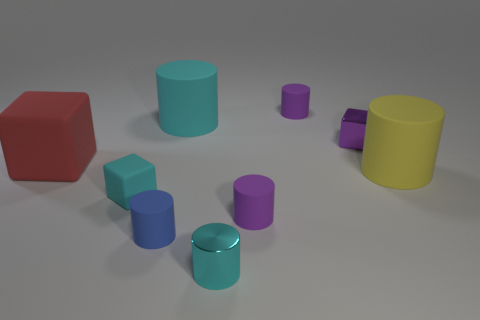Subtract all tiny cylinders. How many cylinders are left? 2 Add 1 large yellow rubber cylinders. How many objects exist? 10 Subtract all cyan cylinders. How many cylinders are left? 4 Subtract all blocks. How many objects are left? 6 Add 6 purple rubber things. How many purple rubber things are left? 8 Add 4 yellow cylinders. How many yellow cylinders exist? 5 Subtract 0 green cylinders. How many objects are left? 9 Subtract 5 cylinders. How many cylinders are left? 1 Subtract all yellow cubes. Subtract all yellow spheres. How many cubes are left? 3 Subtract all blue balls. How many green cylinders are left? 0 